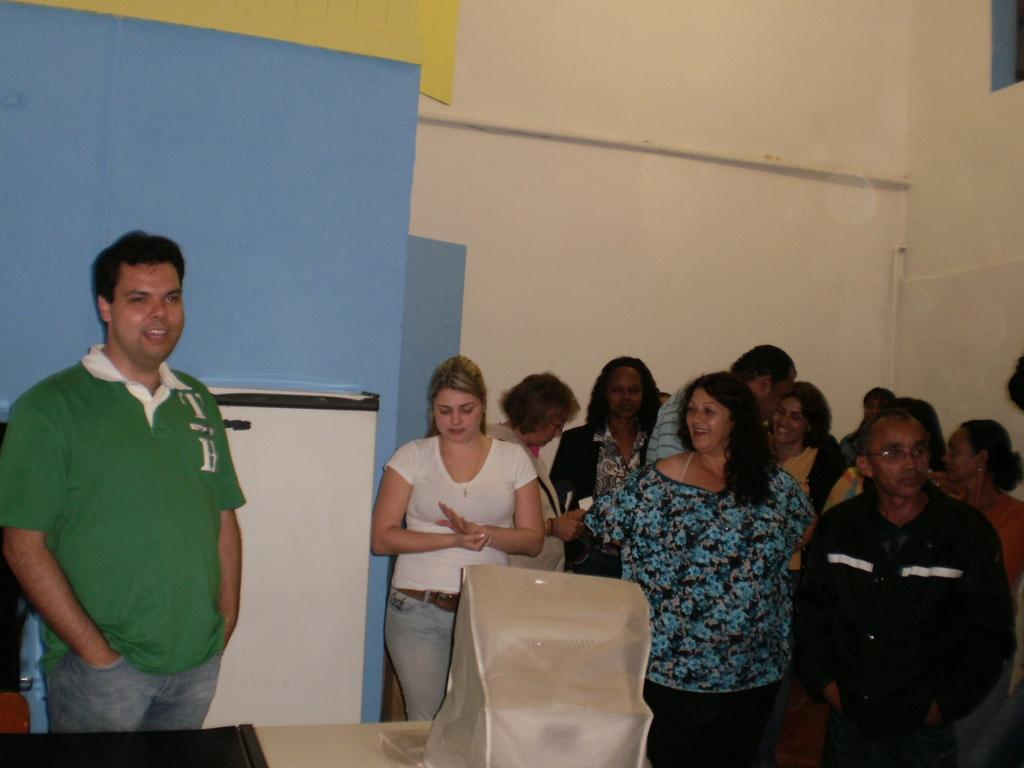What is happening in the image? There are people standing in the image. What can be seen in front of one of the people? There is a monitor with a cover in front of one of the people. What is on the table in the image? There is a black object on the table. What is visible behind one of the people? There is a white object behind one of the people. What is visible in the background of the image? There is a wall visible in the background of the image. What type of prison is depicted in the image? There is no prison present in the image; it features people standing with various objects around them. What knowledge is being shared or gained in the image? The image does not depict any specific knowledge being shared or gained; it simply shows people standing with objects around them. 